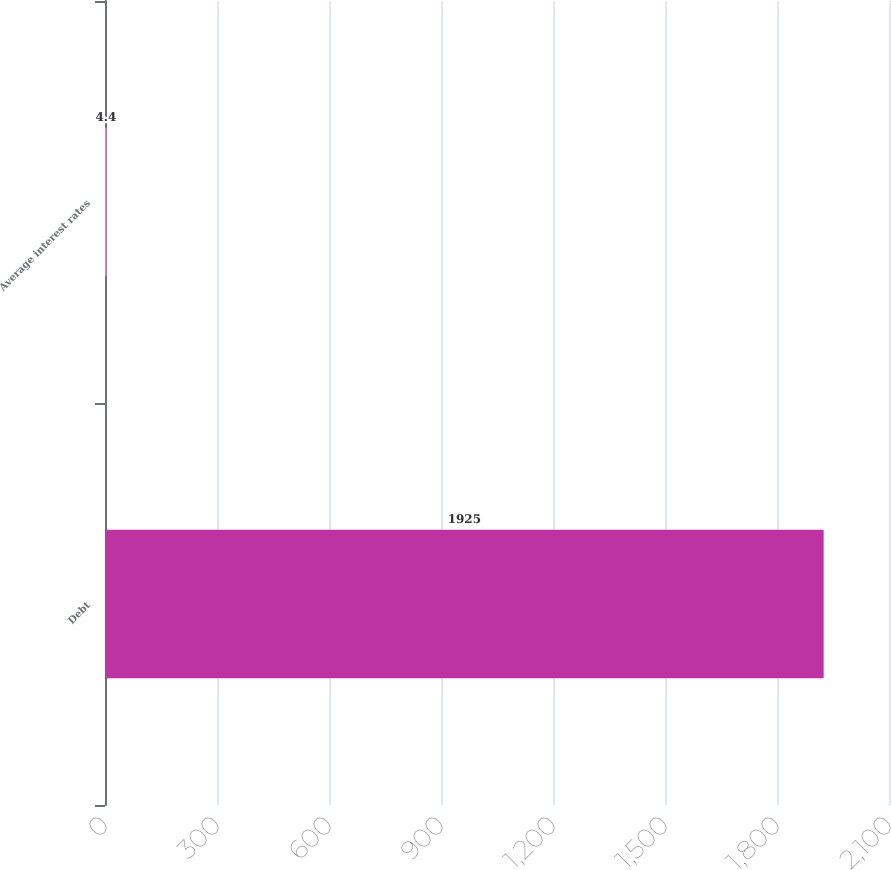Convert chart to OTSL. <chart><loc_0><loc_0><loc_500><loc_500><bar_chart><fcel>Debt<fcel>Average interest rates<nl><fcel>1925<fcel>4.4<nl></chart> 